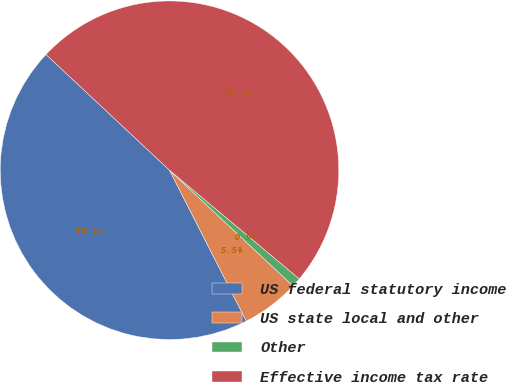Convert chart. <chart><loc_0><loc_0><loc_500><loc_500><pie_chart><fcel>US federal statutory income<fcel>US state local and other<fcel>Other<fcel>Effective income tax rate<nl><fcel>44.48%<fcel>5.52%<fcel>0.89%<fcel>49.11%<nl></chart> 